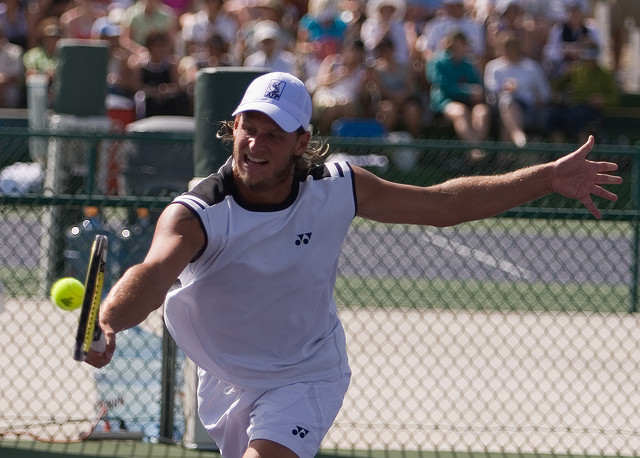<image>What brand of clothing is her outfit? I don't know what brand of clothing her outfit is. It could be a sports brand such as Adidas or Nike. What brand of clothing is her outfit? I am not sure what brand of clothing her outfit is. It could be 'sports brand', 'adidas', 'nike', or 'topper'. 